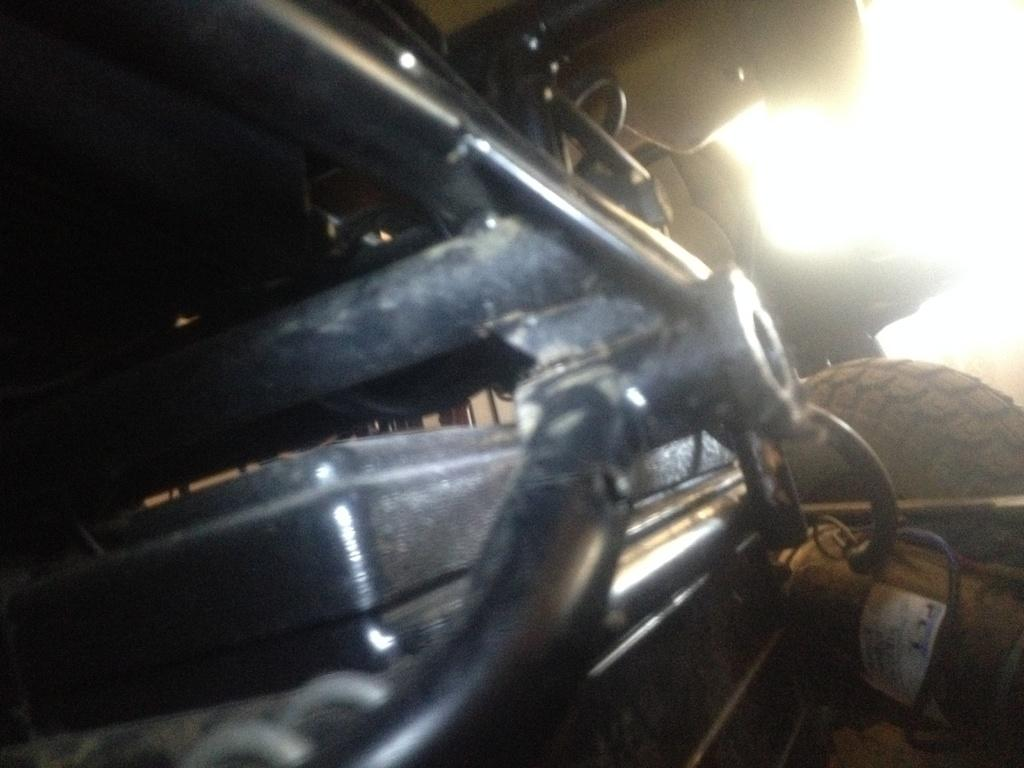What is the main subject of the image? The main subject of the image is a car. Where is the car located in the image? The car is on the ground in the image. What is the perspective of the image? The image provides a closer view of the car. Which part of the car can be seen in the image? The car's tire is visible in the image, as well as other automobile components. What type of disgust can be seen on the judge's face in the image? There is no judge or any indication of disgust in the image; it features a car. 